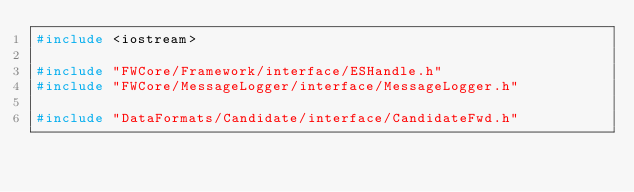<code> <loc_0><loc_0><loc_500><loc_500><_C++_>#include <iostream>

#include "FWCore/Framework/interface/ESHandle.h"
#include "FWCore/MessageLogger/interface/MessageLogger.h"

#include "DataFormats/Candidate/interface/CandidateFwd.h"</code> 